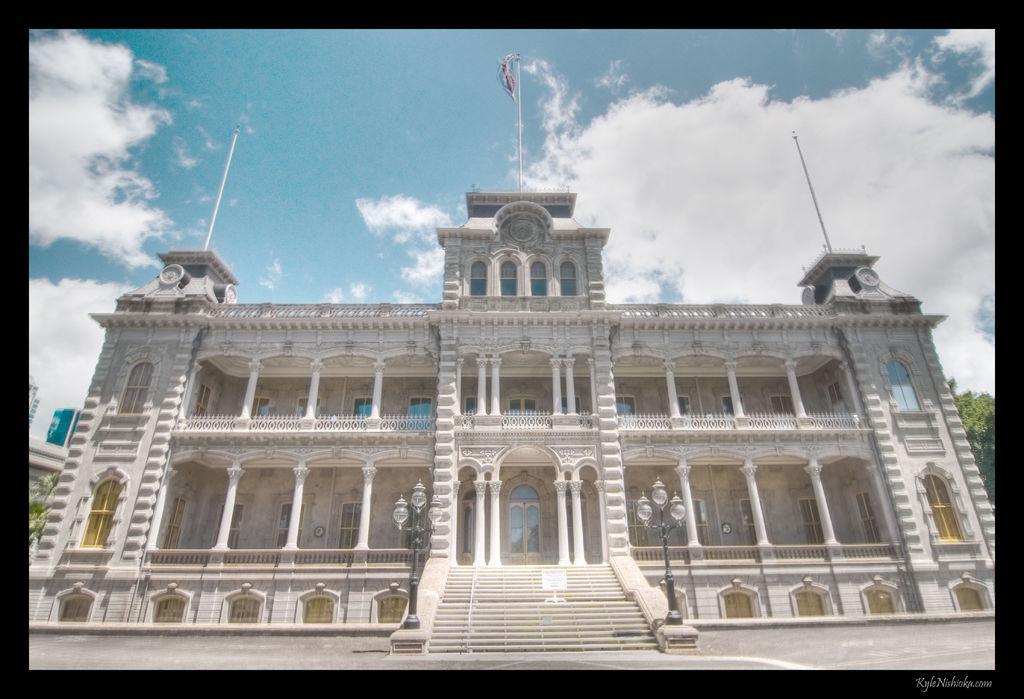Could you give a brief overview of what you see in this image? In this image we can see a building with group of poles, windows, doors, staircase, two light poles and a flag on the pole. In the background we can see trees and the cloudy sky. 